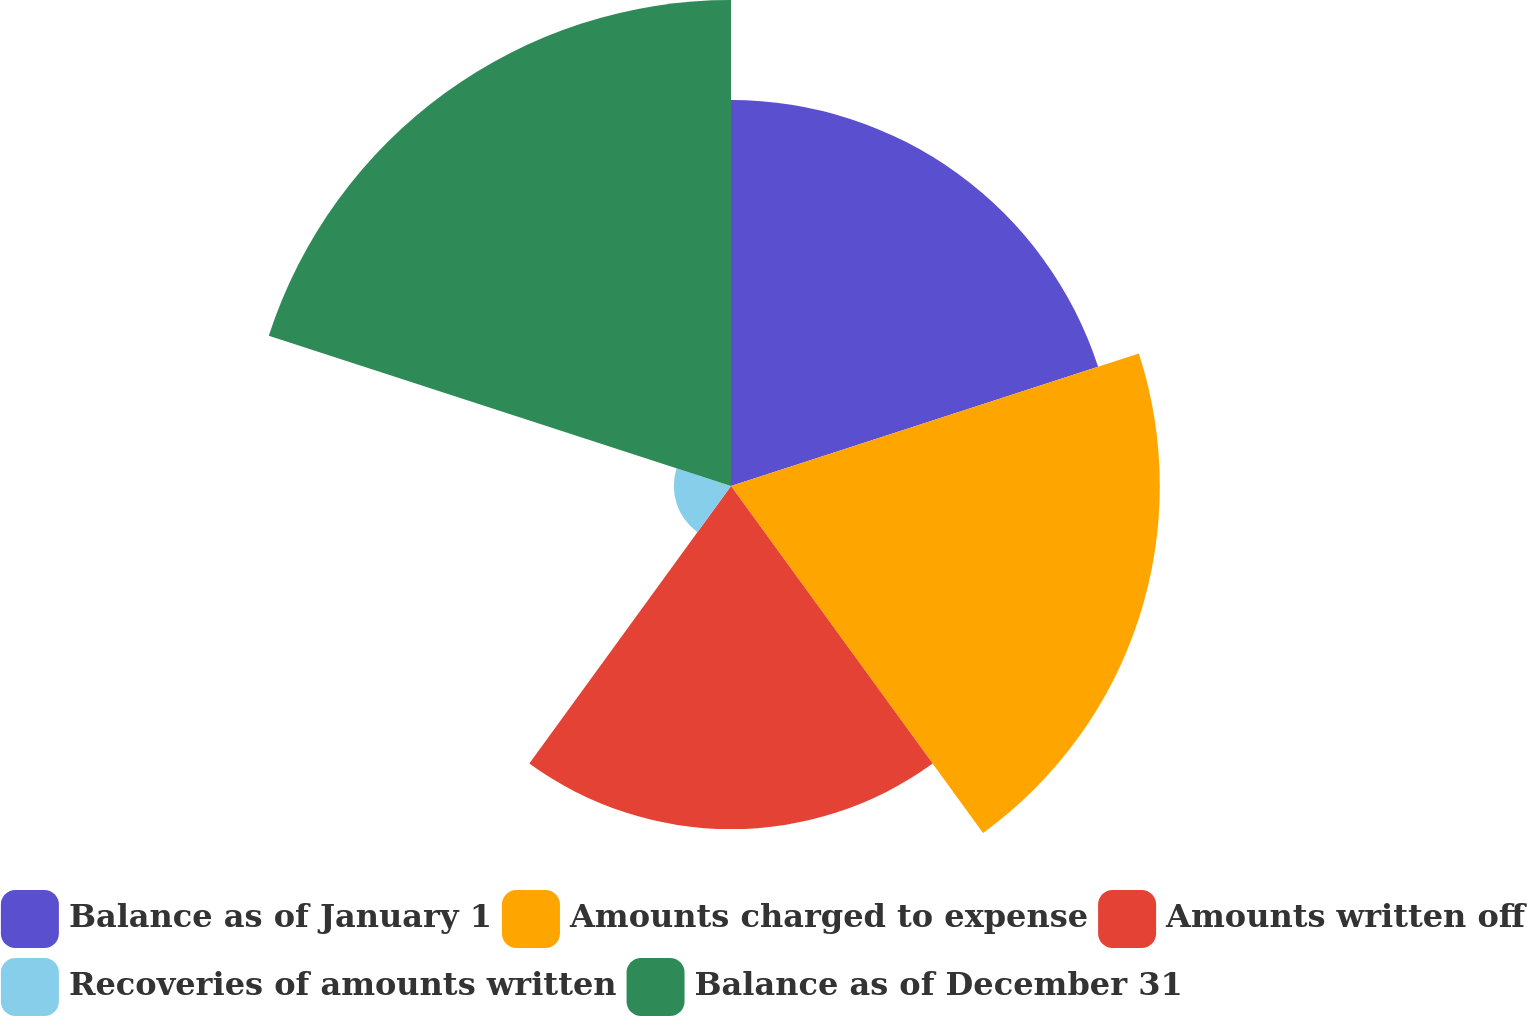<chart> <loc_0><loc_0><loc_500><loc_500><pie_chart><fcel>Balance as of January 1<fcel>Amounts charged to expense<fcel>Amounts written off<fcel>Recoveries of amounts written<fcel>Balance as of December 31<nl><fcel>22.69%<fcel>25.21%<fcel>20.17%<fcel>3.36%<fcel>28.57%<nl></chart> 